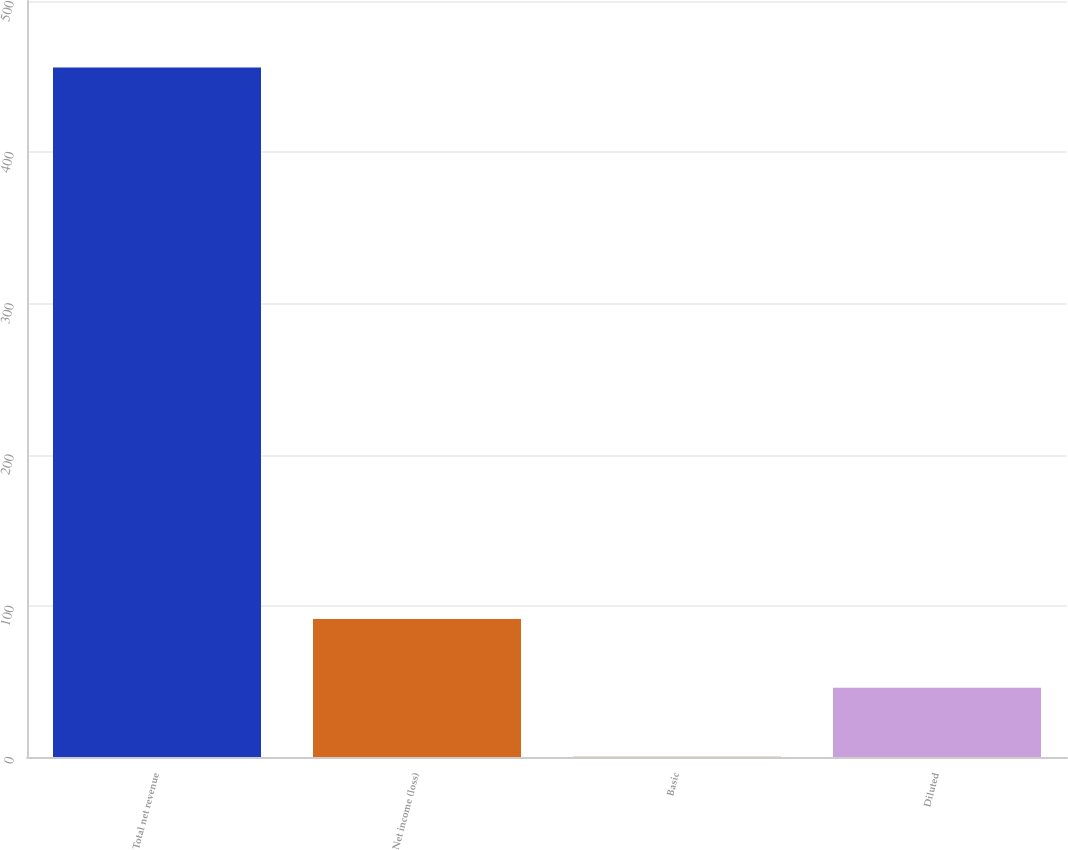<chart> <loc_0><loc_0><loc_500><loc_500><bar_chart><fcel>Total net revenue<fcel>Net income (loss)<fcel>Basic<fcel>Diluted<nl><fcel>456<fcel>91.32<fcel>0.14<fcel>45.73<nl></chart> 